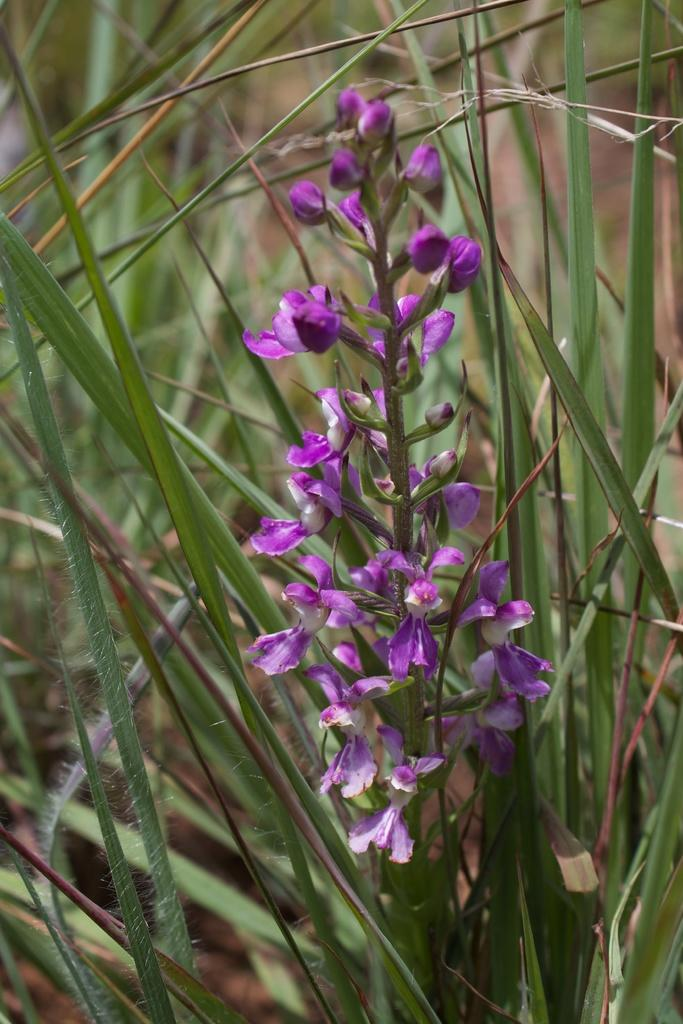What type of living organisms can be seen in the image? Plants can be seen in the image. What color are the flowers on the plants in the image? There are purple flowers in the image. What flavor of thread can be seen in the image? There is no thread present in the image, so it is not possible to determine its flavor. 